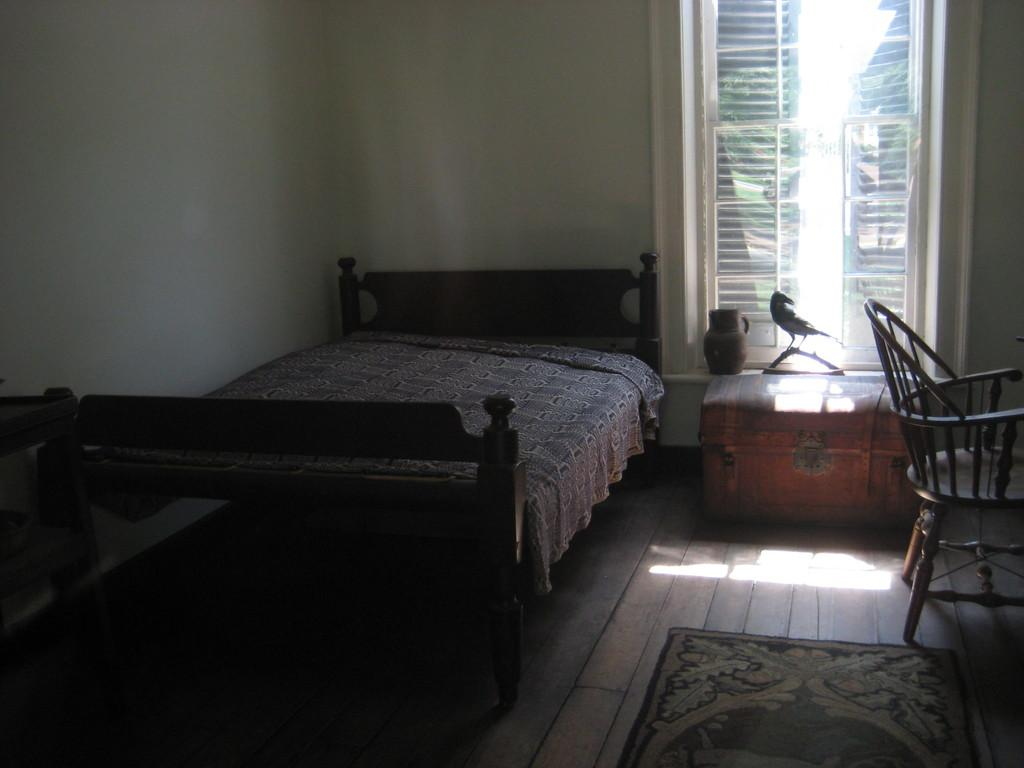What type of furniture is present in the image? There is a bed and a chair in the image. What other objects can be seen in the image? There is a box in the image. What is visible in the background of the image? There is a wall in the background of the image. What architectural feature is present in the wall? There is a window in the wall. What type of flooring is present in the image? There is a mat on a wooden floor. What type of insurance policy is mentioned in the image? There is no mention of any insurance policy in the image. What type of map is visible on the wall in the image? There is no map present in the image; only a window is visible in the wall. 